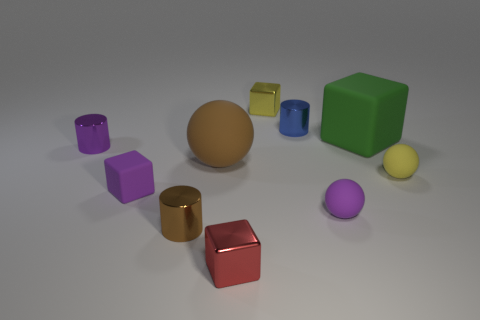There is a cylinder that is to the left of the small brown metallic cylinder; what number of red objects are right of it? There is one red object positioned to the right of the small brown metallic cylinder—a red cube that appears to stand out due to its vibrant color and reflective surface. 